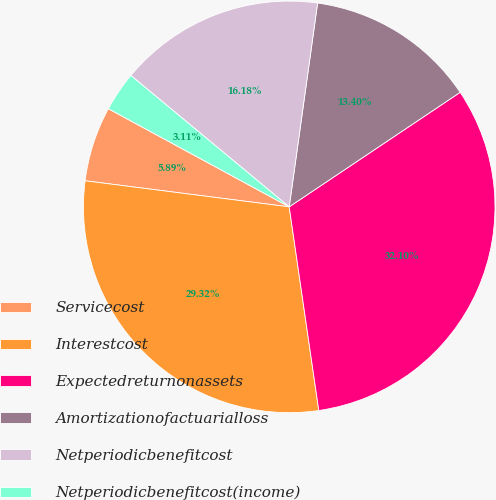Convert chart. <chart><loc_0><loc_0><loc_500><loc_500><pie_chart><fcel>Servicecost<fcel>Interestcost<fcel>Expectedreturnonassets<fcel>Amortizationofactuarialloss<fcel>Netperiodicbenefitcost<fcel>Netperiodicbenefitcost(income)<nl><fcel>5.89%<fcel>29.32%<fcel>32.1%<fcel>13.4%<fcel>16.18%<fcel>3.11%<nl></chart> 